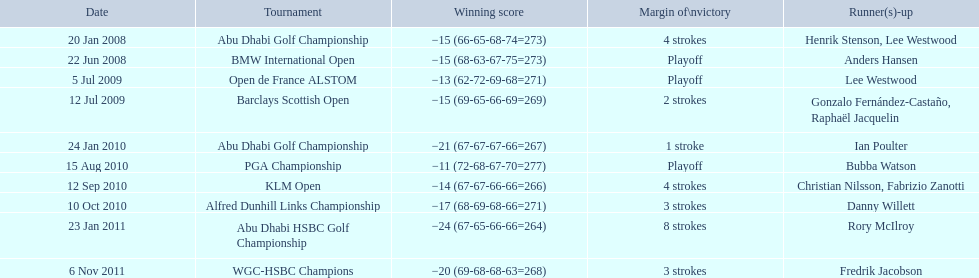What were all the different tournaments played by martin kaymer Abu Dhabi Golf Championship, BMW International Open, Open de France ALSTOM, Barclays Scottish Open, Abu Dhabi Golf Championship, PGA Championship, KLM Open, Alfred Dunhill Links Championship, Abu Dhabi HSBC Golf Championship, WGC-HSBC Champions. Who was the runner-up for the pga championship? Bubba Watson. 